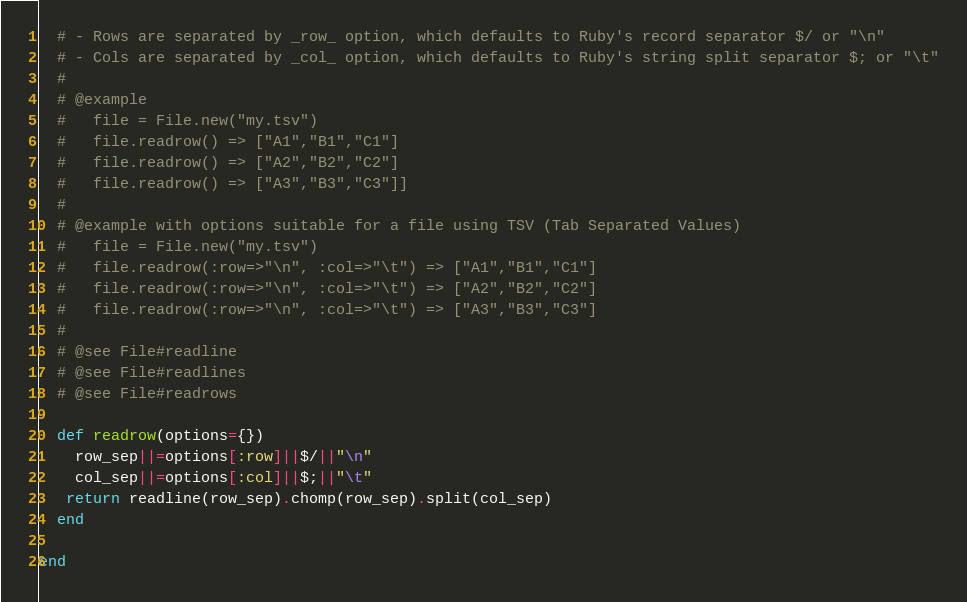<code> <loc_0><loc_0><loc_500><loc_500><_Ruby_>  # - Rows are separated by _row_ option, which defaults to Ruby's record separator $/ or "\n" 
  # - Cols are separated by _col_ option, which defaults to Ruby's string split separator $; or "\t"
  #
  # @example
  #   file = File.new("my.tsv")
  #   file.readrow() => ["A1","B1","C1"]
  #   file.readrow() => ["A2","B2","C2"]
  #   file.readrow() => ["A3","B3","C3"]]
  #
  # @example with options suitable for a file using TSV (Tab Separated Values)
  #   file = File.new("my.tsv")
  #   file.readrow(:row=>"\n", :col=>"\t") => ["A1","B1","C1"] 
  #   file.readrow(:row=>"\n", :col=>"\t") => ["A2","B2","C2"] 
  #   file.readrow(:row=>"\n", :col=>"\t") => ["A3","B3","C3"] 
  #
  # @see File#readline
  # @see File#readlines
  # @see File#readrows

  def readrow(options={})
    row_sep||=options[:row]||$/||"\n"
    col_sep||=options[:col]||$;||"\t"
   return readline(row_sep).chomp(row_sep).split(col_sep)
  end

end
</code> 